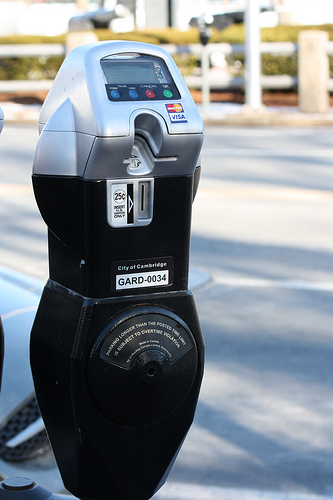Please provide a short description for this region: [0.5, 0.22, 0.53, 0.24]. This region captures a small sticker with the Visa logo, indicating that Visa cards are accepted for payment at this meter. It's a crucial detail for users who might prefer or need to use credit for their parking expenses. 